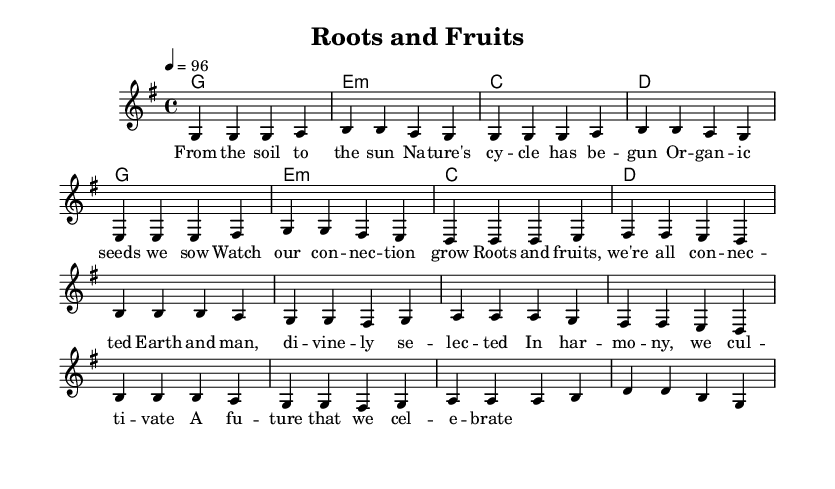What is the key signature of this music? The key signature is G major, which has one sharp (F#). This can be identified by looking at the key signature indication at the beginning of the staff.
Answer: G major What is the time signature of this piece? The time signature is 4/4, which indicates that there are four beats in each measure and a quarter note gets one beat. This is noted at the beginning of the piece.
Answer: 4/4 What is the tempo marking for the piece? The tempo marking is 96 beats per minute, which is indicated at the beginning of the score with the instruction "4 = 96." This shows how fast the piece should be played.
Answer: 96 How many measures are in the verse section? The verse section consists of four measures, as seen when counting the grouped measures in the melody. Each sequence is delineated by the vertical bar lines.
Answer: Four What is the main theme of the chorus lyrics? The main theme of the chorus highlights the connection between nature and humanity, emphasizing harmony and celebration of a shared future. This is inferred from the repetitive and positive language in the lyrics.
Answer: Connection Which musical technique is emphasized in reggae music demonstrated here? The piece features offbeat rhythms, commonly known as the "one drop" rhythm in reggae, which creates a laid-back and groovy feel typical of the genre. This can be detected by the placement of the notes and the chord progressions that support the melody.
Answer: Offbeat rhythms What are the first two words of the song title? The first two words of the song title are "Roots and," as indicated at the top of the sheet music under the title section.
Answer: Roots and 